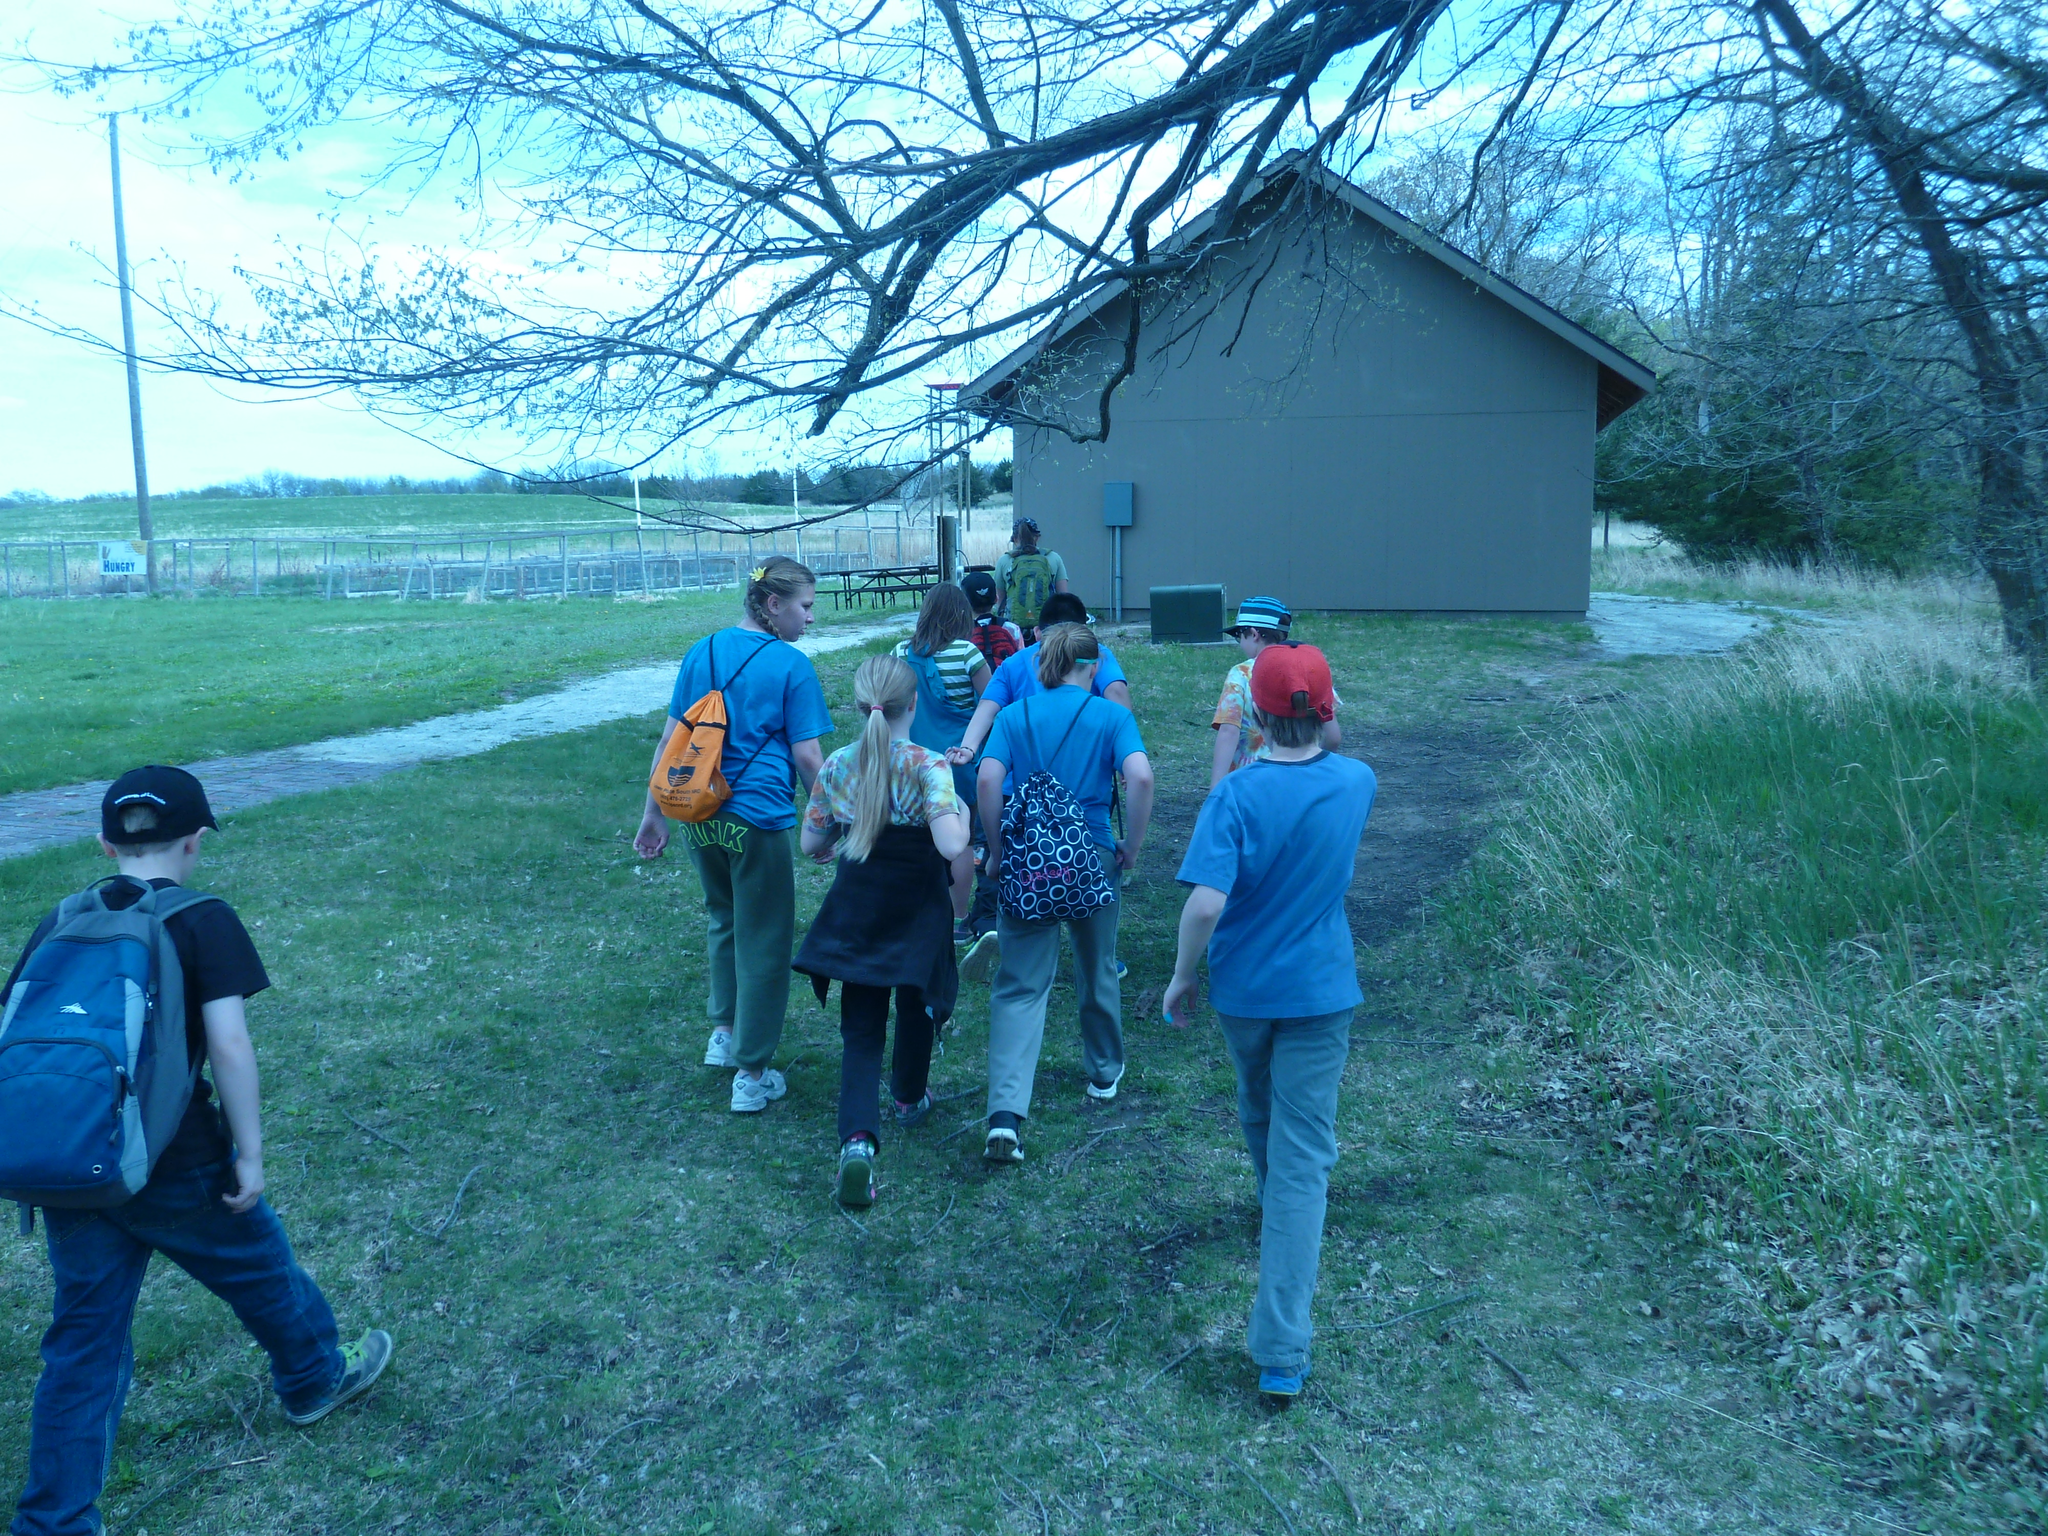How would you summarize this image in a sentence or two? This image consists of many persons walking. They are wearing backpacks. At the bottom, there is green grass. On the right, there are trees. On the left, we can see a fencing along with a pole. At the top, there is sky. 